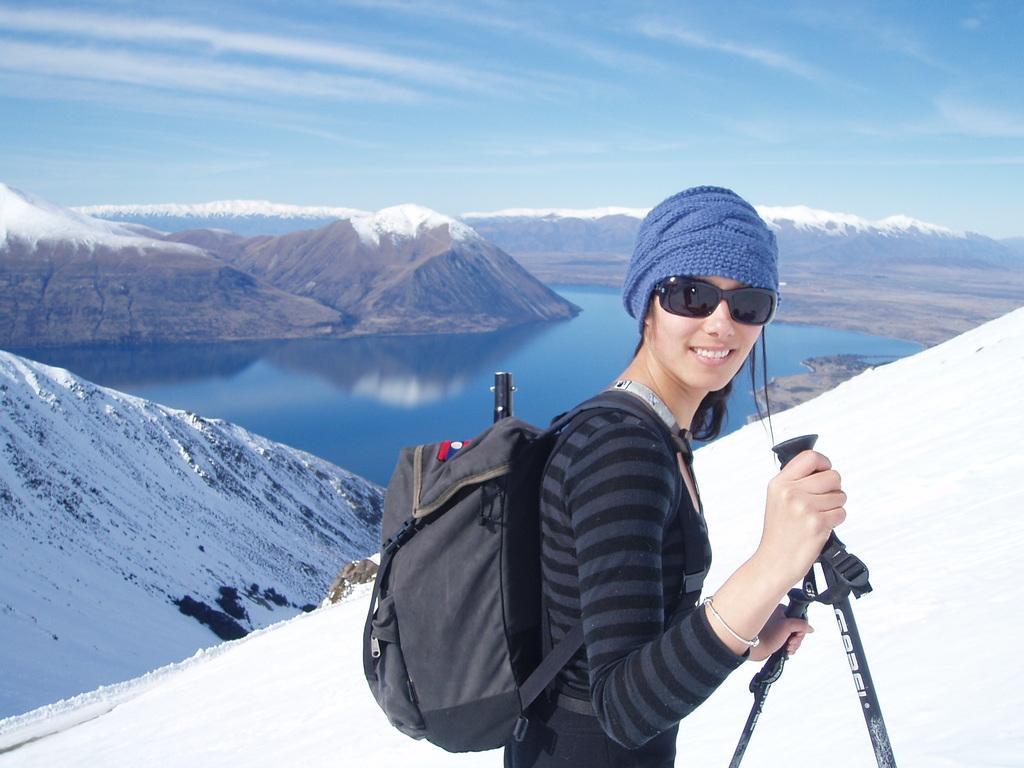In one or two sentences, can you explain what this image depicts? This picture is consists of a snow place at the left side of the image and there is a girl who is standing at the center of the image she is wearing a cap, sun glasses, and bag, there are snow mountains around the area of the image. 